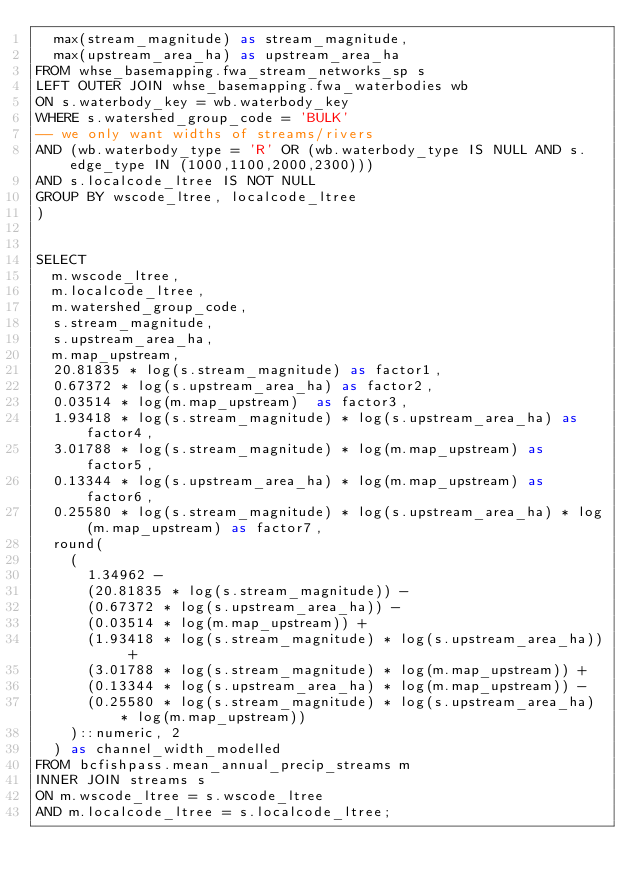<code> <loc_0><loc_0><loc_500><loc_500><_SQL_>  max(stream_magnitude) as stream_magnitude,
  max(upstream_area_ha) as upstream_area_ha
FROM whse_basemapping.fwa_stream_networks_sp s
LEFT OUTER JOIN whse_basemapping.fwa_waterbodies wb
ON s.waterbody_key = wb.waterbody_key
WHERE s.watershed_group_code = 'BULK'
-- we only want widths of streams/rivers
AND (wb.waterbody_type = 'R' OR (wb.waterbody_type IS NULL AND s.edge_type IN (1000,1100,2000,2300)))
AND s.localcode_ltree IS NOT NULL
GROUP BY wscode_ltree, localcode_ltree
)


SELECT
  m.wscode_ltree,
  m.localcode_ltree,
  m.watershed_group_code,
  s.stream_magnitude,
  s.upstream_area_ha,
  m.map_upstream,
  20.81835 * log(s.stream_magnitude) as factor1,
  0.67372 * log(s.upstream_area_ha) as factor2,
  0.03514 * log(m.map_upstream)  as factor3,
  1.93418 * log(s.stream_magnitude) * log(s.upstream_area_ha) as factor4,
  3.01788 * log(s.stream_magnitude) * log(m.map_upstream) as factor5,
  0.13344 * log(s.upstream_area_ha) * log(m.map_upstream) as factor6,
  0.25580 * log(s.stream_magnitude) * log(s.upstream_area_ha) * log(m.map_upstream) as factor7,
  round(
    (
      1.34962 -
      (20.81835 * log(s.stream_magnitude)) -
      (0.67372 * log(s.upstream_area_ha)) -
      (0.03514 * log(m.map_upstream)) +
      (1.93418 * log(s.stream_magnitude) * log(s.upstream_area_ha)) +
      (3.01788 * log(s.stream_magnitude) * log(m.map_upstream)) +
      (0.13344 * log(s.upstream_area_ha) * log(m.map_upstream)) -
      (0.25580 * log(s.stream_magnitude) * log(s.upstream_area_ha) * log(m.map_upstream))
    )::numeric, 2
  ) as channel_width_modelled
FROM bcfishpass.mean_annual_precip_streams m
INNER JOIN streams s
ON m.wscode_ltree = s.wscode_ltree
AND m.localcode_ltree = s.localcode_ltree;</code> 